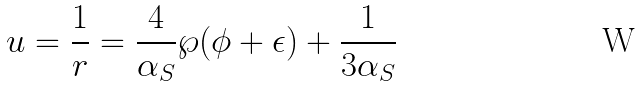Convert formula to latex. <formula><loc_0><loc_0><loc_500><loc_500>u = \frac { 1 } { r } = \frac { 4 } { \alpha _ { S } } \wp ( \phi + \epsilon ) + \frac { 1 } { 3 \alpha _ { S } }</formula> 